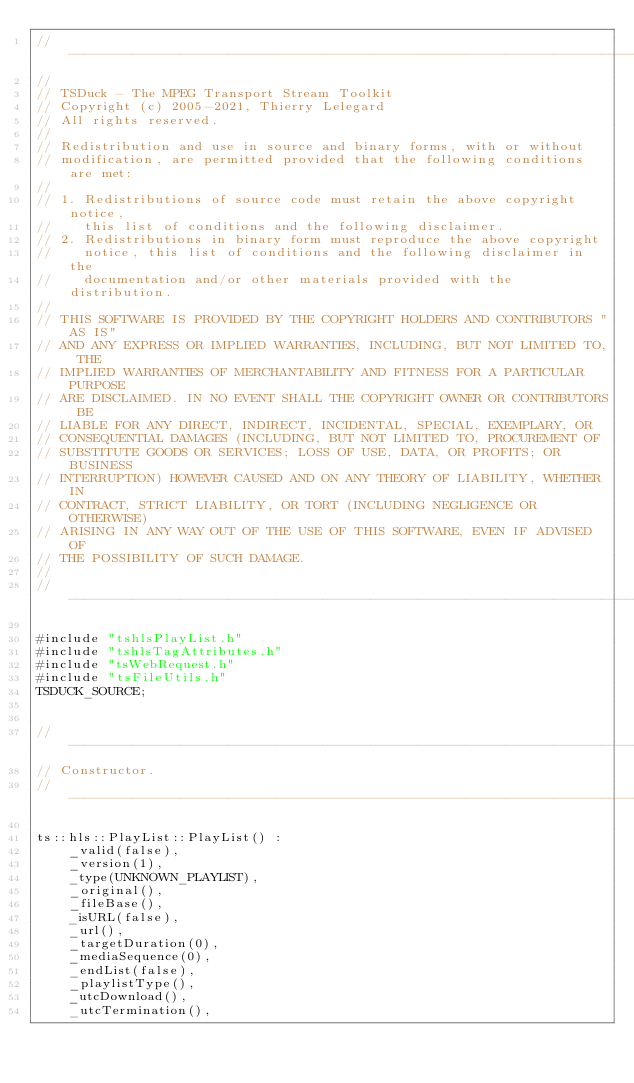<code> <loc_0><loc_0><loc_500><loc_500><_C++_>//----------------------------------------------------------------------------
//
// TSDuck - The MPEG Transport Stream Toolkit
// Copyright (c) 2005-2021, Thierry Lelegard
// All rights reserved.
//
// Redistribution and use in source and binary forms, with or without
// modification, are permitted provided that the following conditions are met:
//
// 1. Redistributions of source code must retain the above copyright notice,
//    this list of conditions and the following disclaimer.
// 2. Redistributions in binary form must reproduce the above copyright
//    notice, this list of conditions and the following disclaimer in the
//    documentation and/or other materials provided with the distribution.
//
// THIS SOFTWARE IS PROVIDED BY THE COPYRIGHT HOLDERS AND CONTRIBUTORS "AS IS"
// AND ANY EXPRESS OR IMPLIED WARRANTIES, INCLUDING, BUT NOT LIMITED TO, THE
// IMPLIED WARRANTIES OF MERCHANTABILITY AND FITNESS FOR A PARTICULAR PURPOSE
// ARE DISCLAIMED. IN NO EVENT SHALL THE COPYRIGHT OWNER OR CONTRIBUTORS BE
// LIABLE FOR ANY DIRECT, INDIRECT, INCIDENTAL, SPECIAL, EXEMPLARY, OR
// CONSEQUENTIAL DAMAGES (INCLUDING, BUT NOT LIMITED TO, PROCUREMENT OF
// SUBSTITUTE GOODS OR SERVICES; LOSS OF USE, DATA, OR PROFITS; OR BUSINESS
// INTERRUPTION) HOWEVER CAUSED AND ON ANY THEORY OF LIABILITY, WHETHER IN
// CONTRACT, STRICT LIABILITY, OR TORT (INCLUDING NEGLIGENCE OR OTHERWISE)
// ARISING IN ANY WAY OUT OF THE USE OF THIS SOFTWARE, EVEN IF ADVISED OF
// THE POSSIBILITY OF SUCH DAMAGE.
//
//----------------------------------------------------------------------------

#include "tshlsPlayList.h"
#include "tshlsTagAttributes.h"
#include "tsWebRequest.h"
#include "tsFileUtils.h"
TSDUCK_SOURCE;


//----------------------------------------------------------------------------
// Constructor.
//----------------------------------------------------------------------------

ts::hls::PlayList::PlayList() :
    _valid(false),
    _version(1),
    _type(UNKNOWN_PLAYLIST),
    _original(),
    _fileBase(),
    _isURL(false),
    _url(),
    _targetDuration(0),
    _mediaSequence(0),
    _endList(false),
    _playlistType(),
    _utcDownload(),
    _utcTermination(),</code> 